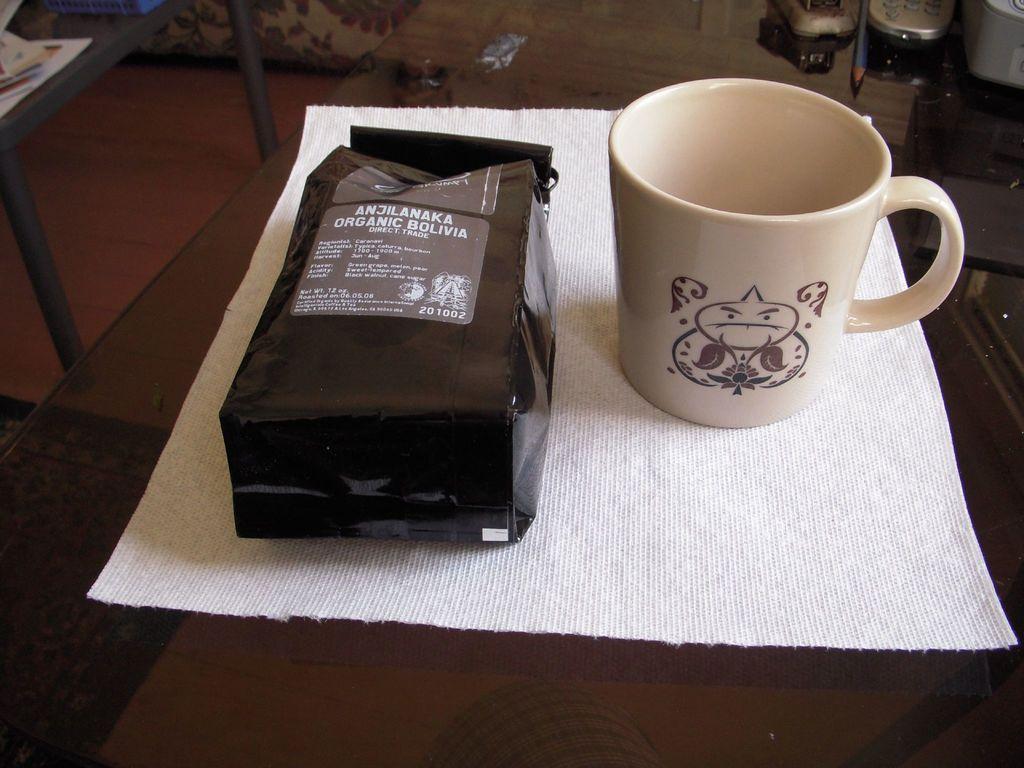Could you give a brief overview of what you see in this image? In front of picture, we see a table on which white cloth, cup and black cover containing sticker are placed and on sticker, we see some text written on it and behind that, we see a great table on which book is placed and cupboard. 